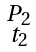<formula> <loc_0><loc_0><loc_500><loc_500>\begin{smallmatrix} P _ { 2 } \\ t _ { 2 } \end{smallmatrix}</formula> 